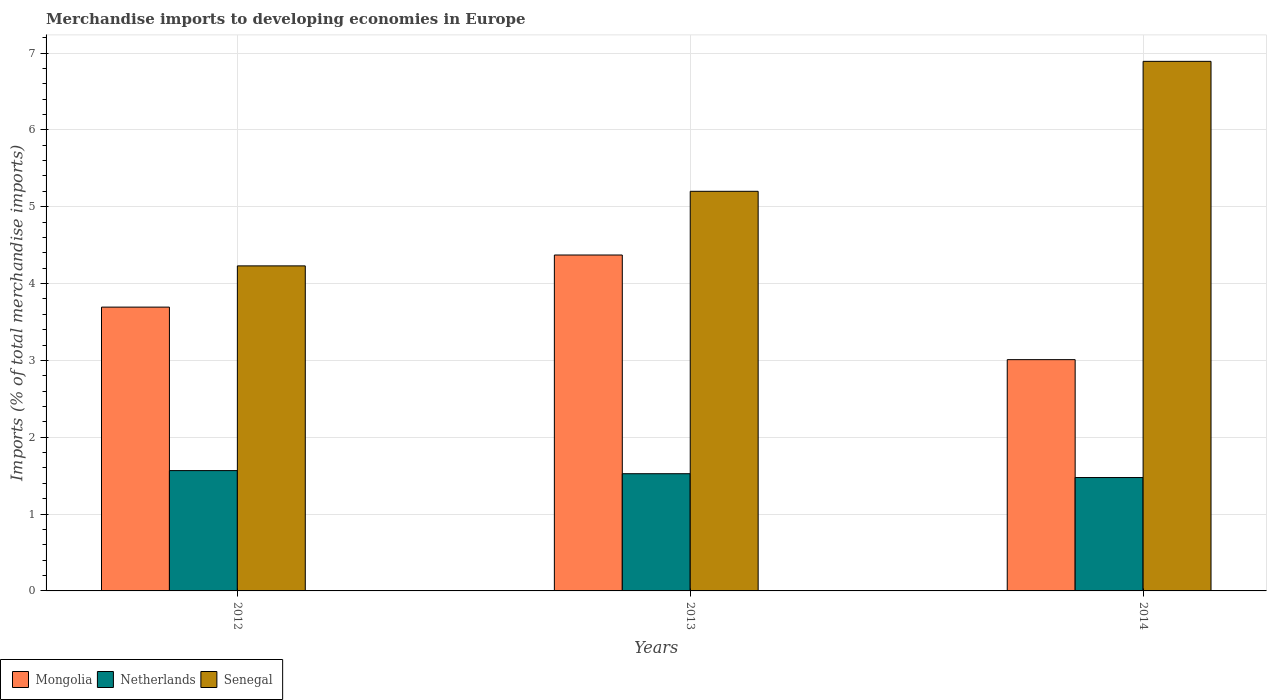How many different coloured bars are there?
Give a very brief answer. 3. Are the number of bars per tick equal to the number of legend labels?
Give a very brief answer. Yes. What is the label of the 1st group of bars from the left?
Give a very brief answer. 2012. In how many cases, is the number of bars for a given year not equal to the number of legend labels?
Provide a short and direct response. 0. What is the percentage total merchandise imports in Senegal in 2012?
Keep it short and to the point. 4.23. Across all years, what is the maximum percentage total merchandise imports in Mongolia?
Provide a short and direct response. 4.37. Across all years, what is the minimum percentage total merchandise imports in Mongolia?
Make the answer very short. 3.01. In which year was the percentage total merchandise imports in Mongolia maximum?
Provide a succinct answer. 2013. What is the total percentage total merchandise imports in Mongolia in the graph?
Your response must be concise. 11.08. What is the difference between the percentage total merchandise imports in Netherlands in 2012 and that in 2014?
Keep it short and to the point. 0.09. What is the difference between the percentage total merchandise imports in Netherlands in 2014 and the percentage total merchandise imports in Mongolia in 2013?
Offer a very short reply. -2.9. What is the average percentage total merchandise imports in Netherlands per year?
Provide a short and direct response. 1.52. In the year 2014, what is the difference between the percentage total merchandise imports in Mongolia and percentage total merchandise imports in Senegal?
Provide a short and direct response. -3.88. In how many years, is the percentage total merchandise imports in Mongolia greater than 3.8 %?
Make the answer very short. 1. What is the ratio of the percentage total merchandise imports in Netherlands in 2012 to that in 2014?
Keep it short and to the point. 1.06. Is the difference between the percentage total merchandise imports in Mongolia in 2013 and 2014 greater than the difference between the percentage total merchandise imports in Senegal in 2013 and 2014?
Give a very brief answer. Yes. What is the difference between the highest and the second highest percentage total merchandise imports in Netherlands?
Offer a very short reply. 0.04. What is the difference between the highest and the lowest percentage total merchandise imports in Netherlands?
Ensure brevity in your answer.  0.09. What does the 3rd bar from the left in 2012 represents?
Provide a short and direct response. Senegal. What does the 1st bar from the right in 2014 represents?
Provide a succinct answer. Senegal. Are all the bars in the graph horizontal?
Make the answer very short. No. What is the difference between two consecutive major ticks on the Y-axis?
Give a very brief answer. 1. Are the values on the major ticks of Y-axis written in scientific E-notation?
Offer a very short reply. No. Does the graph contain any zero values?
Your response must be concise. No. Does the graph contain grids?
Offer a very short reply. Yes. Where does the legend appear in the graph?
Give a very brief answer. Bottom left. How are the legend labels stacked?
Keep it short and to the point. Horizontal. What is the title of the graph?
Provide a succinct answer. Merchandise imports to developing economies in Europe. Does "Solomon Islands" appear as one of the legend labels in the graph?
Offer a terse response. No. What is the label or title of the Y-axis?
Provide a succinct answer. Imports (% of total merchandise imports). What is the Imports (% of total merchandise imports) of Mongolia in 2012?
Make the answer very short. 3.69. What is the Imports (% of total merchandise imports) of Netherlands in 2012?
Make the answer very short. 1.57. What is the Imports (% of total merchandise imports) in Senegal in 2012?
Keep it short and to the point. 4.23. What is the Imports (% of total merchandise imports) of Mongolia in 2013?
Give a very brief answer. 4.37. What is the Imports (% of total merchandise imports) of Netherlands in 2013?
Offer a terse response. 1.53. What is the Imports (% of total merchandise imports) in Senegal in 2013?
Ensure brevity in your answer.  5.2. What is the Imports (% of total merchandise imports) in Mongolia in 2014?
Keep it short and to the point. 3.01. What is the Imports (% of total merchandise imports) in Netherlands in 2014?
Give a very brief answer. 1.48. What is the Imports (% of total merchandise imports) of Senegal in 2014?
Offer a terse response. 6.89. Across all years, what is the maximum Imports (% of total merchandise imports) of Mongolia?
Provide a succinct answer. 4.37. Across all years, what is the maximum Imports (% of total merchandise imports) in Netherlands?
Your response must be concise. 1.57. Across all years, what is the maximum Imports (% of total merchandise imports) in Senegal?
Offer a terse response. 6.89. Across all years, what is the minimum Imports (% of total merchandise imports) of Mongolia?
Your response must be concise. 3.01. Across all years, what is the minimum Imports (% of total merchandise imports) of Netherlands?
Give a very brief answer. 1.48. Across all years, what is the minimum Imports (% of total merchandise imports) in Senegal?
Offer a very short reply. 4.23. What is the total Imports (% of total merchandise imports) in Mongolia in the graph?
Ensure brevity in your answer.  11.08. What is the total Imports (% of total merchandise imports) of Netherlands in the graph?
Make the answer very short. 4.57. What is the total Imports (% of total merchandise imports) in Senegal in the graph?
Offer a very short reply. 16.32. What is the difference between the Imports (% of total merchandise imports) in Mongolia in 2012 and that in 2013?
Make the answer very short. -0.68. What is the difference between the Imports (% of total merchandise imports) of Netherlands in 2012 and that in 2013?
Your answer should be very brief. 0.04. What is the difference between the Imports (% of total merchandise imports) in Senegal in 2012 and that in 2013?
Offer a terse response. -0.97. What is the difference between the Imports (% of total merchandise imports) of Mongolia in 2012 and that in 2014?
Keep it short and to the point. 0.68. What is the difference between the Imports (% of total merchandise imports) of Netherlands in 2012 and that in 2014?
Give a very brief answer. 0.09. What is the difference between the Imports (% of total merchandise imports) of Senegal in 2012 and that in 2014?
Your response must be concise. -2.66. What is the difference between the Imports (% of total merchandise imports) in Mongolia in 2013 and that in 2014?
Ensure brevity in your answer.  1.36. What is the difference between the Imports (% of total merchandise imports) of Netherlands in 2013 and that in 2014?
Give a very brief answer. 0.05. What is the difference between the Imports (% of total merchandise imports) of Senegal in 2013 and that in 2014?
Make the answer very short. -1.69. What is the difference between the Imports (% of total merchandise imports) of Mongolia in 2012 and the Imports (% of total merchandise imports) of Netherlands in 2013?
Make the answer very short. 2.17. What is the difference between the Imports (% of total merchandise imports) in Mongolia in 2012 and the Imports (% of total merchandise imports) in Senegal in 2013?
Provide a succinct answer. -1.51. What is the difference between the Imports (% of total merchandise imports) in Netherlands in 2012 and the Imports (% of total merchandise imports) in Senegal in 2013?
Provide a short and direct response. -3.63. What is the difference between the Imports (% of total merchandise imports) of Mongolia in 2012 and the Imports (% of total merchandise imports) of Netherlands in 2014?
Offer a very short reply. 2.22. What is the difference between the Imports (% of total merchandise imports) of Mongolia in 2012 and the Imports (% of total merchandise imports) of Senegal in 2014?
Keep it short and to the point. -3.2. What is the difference between the Imports (% of total merchandise imports) in Netherlands in 2012 and the Imports (% of total merchandise imports) in Senegal in 2014?
Your response must be concise. -5.33. What is the difference between the Imports (% of total merchandise imports) in Mongolia in 2013 and the Imports (% of total merchandise imports) in Netherlands in 2014?
Offer a terse response. 2.9. What is the difference between the Imports (% of total merchandise imports) in Mongolia in 2013 and the Imports (% of total merchandise imports) in Senegal in 2014?
Offer a terse response. -2.52. What is the difference between the Imports (% of total merchandise imports) in Netherlands in 2013 and the Imports (% of total merchandise imports) in Senegal in 2014?
Provide a succinct answer. -5.37. What is the average Imports (% of total merchandise imports) of Mongolia per year?
Keep it short and to the point. 3.69. What is the average Imports (% of total merchandise imports) of Netherlands per year?
Provide a short and direct response. 1.52. What is the average Imports (% of total merchandise imports) of Senegal per year?
Provide a short and direct response. 5.44. In the year 2012, what is the difference between the Imports (% of total merchandise imports) of Mongolia and Imports (% of total merchandise imports) of Netherlands?
Give a very brief answer. 2.13. In the year 2012, what is the difference between the Imports (% of total merchandise imports) of Mongolia and Imports (% of total merchandise imports) of Senegal?
Your response must be concise. -0.54. In the year 2012, what is the difference between the Imports (% of total merchandise imports) of Netherlands and Imports (% of total merchandise imports) of Senegal?
Give a very brief answer. -2.66. In the year 2013, what is the difference between the Imports (% of total merchandise imports) of Mongolia and Imports (% of total merchandise imports) of Netherlands?
Offer a very short reply. 2.85. In the year 2013, what is the difference between the Imports (% of total merchandise imports) in Mongolia and Imports (% of total merchandise imports) in Senegal?
Provide a short and direct response. -0.83. In the year 2013, what is the difference between the Imports (% of total merchandise imports) in Netherlands and Imports (% of total merchandise imports) in Senegal?
Your response must be concise. -3.68. In the year 2014, what is the difference between the Imports (% of total merchandise imports) in Mongolia and Imports (% of total merchandise imports) in Netherlands?
Your answer should be compact. 1.53. In the year 2014, what is the difference between the Imports (% of total merchandise imports) in Mongolia and Imports (% of total merchandise imports) in Senegal?
Give a very brief answer. -3.88. In the year 2014, what is the difference between the Imports (% of total merchandise imports) of Netherlands and Imports (% of total merchandise imports) of Senegal?
Offer a terse response. -5.42. What is the ratio of the Imports (% of total merchandise imports) of Mongolia in 2012 to that in 2013?
Make the answer very short. 0.84. What is the ratio of the Imports (% of total merchandise imports) in Netherlands in 2012 to that in 2013?
Your answer should be very brief. 1.03. What is the ratio of the Imports (% of total merchandise imports) of Senegal in 2012 to that in 2013?
Offer a very short reply. 0.81. What is the ratio of the Imports (% of total merchandise imports) in Mongolia in 2012 to that in 2014?
Your answer should be compact. 1.23. What is the ratio of the Imports (% of total merchandise imports) of Netherlands in 2012 to that in 2014?
Keep it short and to the point. 1.06. What is the ratio of the Imports (% of total merchandise imports) in Senegal in 2012 to that in 2014?
Your response must be concise. 0.61. What is the ratio of the Imports (% of total merchandise imports) in Mongolia in 2013 to that in 2014?
Your answer should be compact. 1.45. What is the ratio of the Imports (% of total merchandise imports) of Netherlands in 2013 to that in 2014?
Your answer should be very brief. 1.03. What is the ratio of the Imports (% of total merchandise imports) of Senegal in 2013 to that in 2014?
Give a very brief answer. 0.75. What is the difference between the highest and the second highest Imports (% of total merchandise imports) in Mongolia?
Provide a short and direct response. 0.68. What is the difference between the highest and the second highest Imports (% of total merchandise imports) of Netherlands?
Offer a very short reply. 0.04. What is the difference between the highest and the second highest Imports (% of total merchandise imports) of Senegal?
Your answer should be compact. 1.69. What is the difference between the highest and the lowest Imports (% of total merchandise imports) of Mongolia?
Offer a terse response. 1.36. What is the difference between the highest and the lowest Imports (% of total merchandise imports) of Netherlands?
Provide a succinct answer. 0.09. What is the difference between the highest and the lowest Imports (% of total merchandise imports) in Senegal?
Provide a short and direct response. 2.66. 